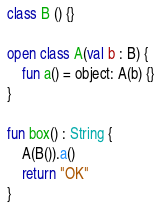Convert code to text. <code><loc_0><loc_0><loc_500><loc_500><_Kotlin_>class B () {}

open class A(val b : B) {
    fun a() = object: A(b) {}
}

fun box() : String {
    A(B()).a()
    return "OK"
}
</code> 